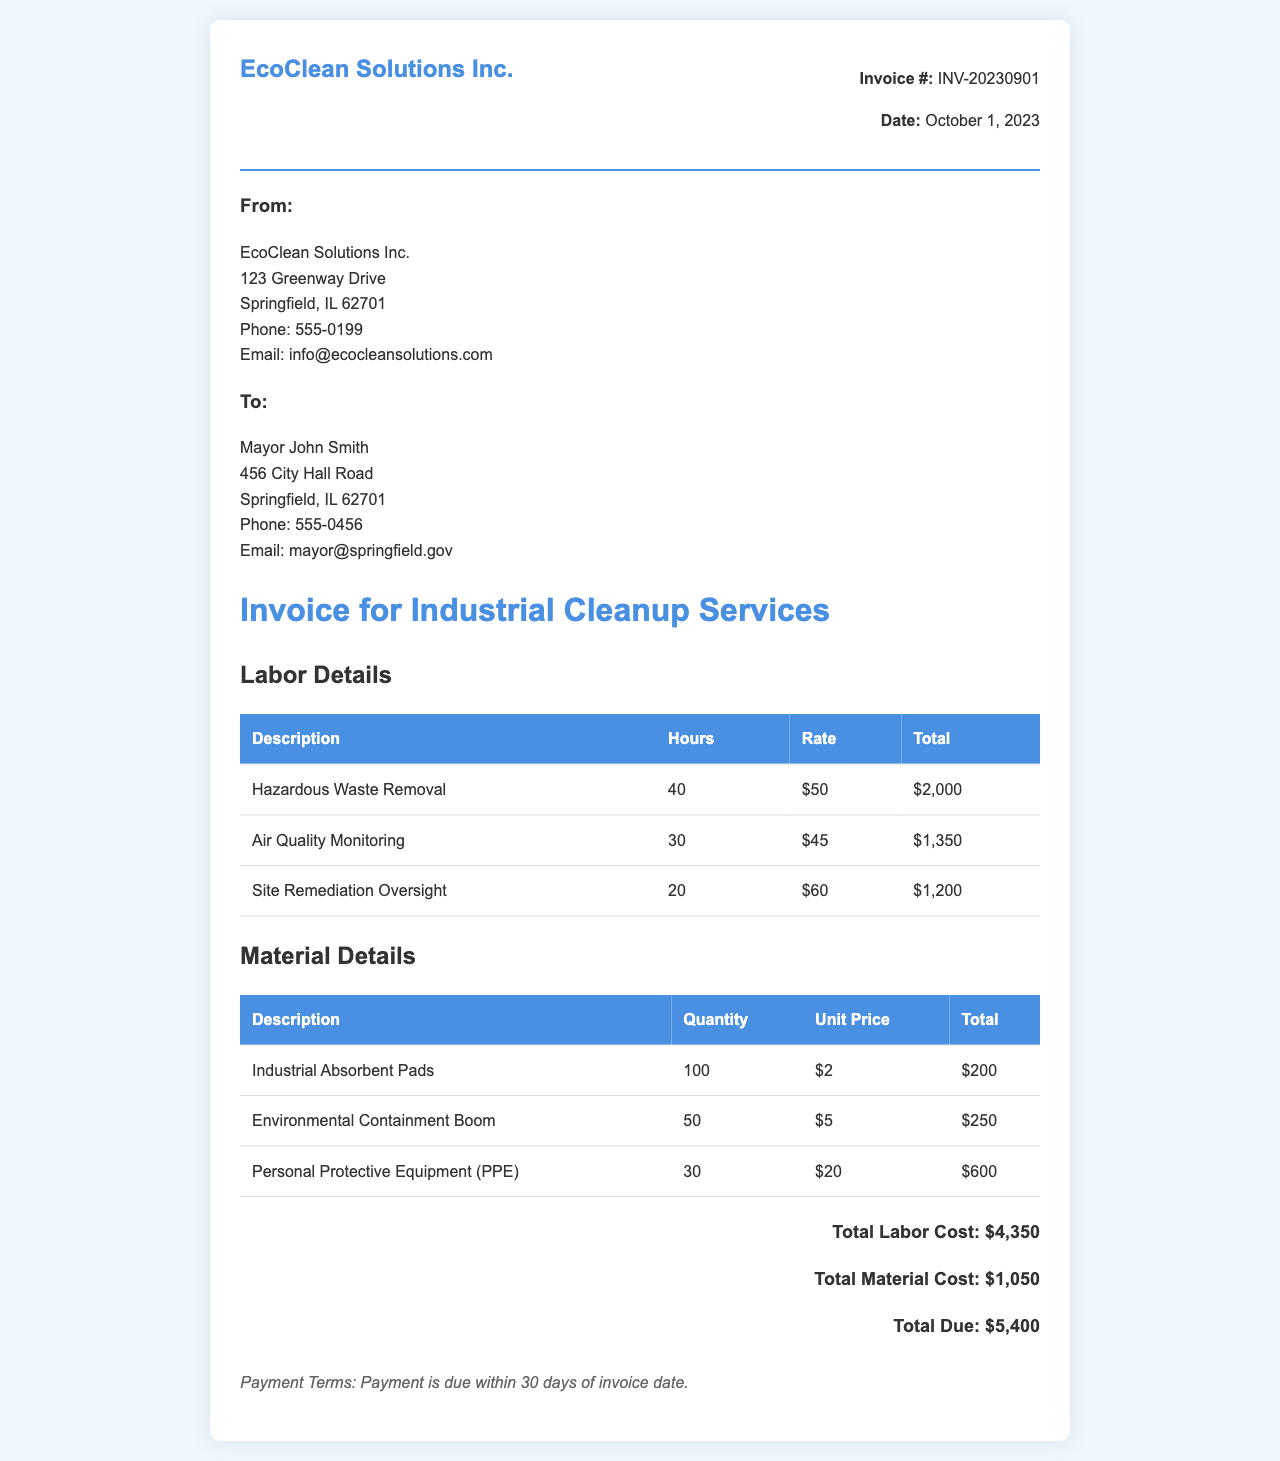What is the invoice number? The invoice number is indicated at the top of the invoice document.
Answer: INV-20230901 What is the total labor cost? The total labor cost is calculated from the labor details section of the invoice.
Answer: $4,350 What is the quantity of Industrial Absorbent Pads? The quantity is specified in the material details section of the invoice.
Answer: 100 What is the rate for Air Quality Monitoring? The rate is provided in the labor details table for that specific task.
Answer: $45 How many total hours were billed for Site Remediation Oversight? The total hours are summed up from the labor details section for that service.
Answer: 20 What is the total due amount? The total due is the sum of total labor and material costs listed at the bottom of the invoice.
Answer: $5,400 Who is the invoice addressed to? The recipient's name is mentioned at the top of the invoice under the "To" section.
Answer: Mayor John Smith What is the payment term? The payment terms are listed towards the end of the invoice document.
Answer: 30 days What is the unit price for Personal Protective Equipment (PPE)? The unit price is specified in the material details section of the invoice.
Answer: $20 